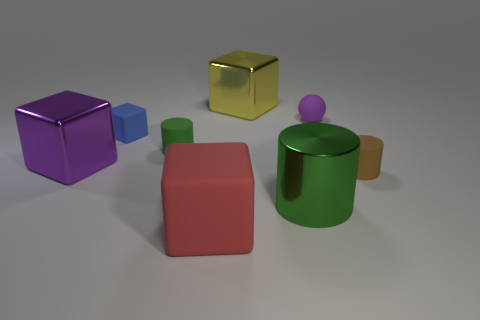Can you describe the lighting and shadows observed in the scene? Certainly! The lighting in the scene is soft and diffused, creating gentle shadows that stretch away from the objects. It appears that the light source is above the objects, slightly off to the left, creating a natural and relaxed ambiance. 